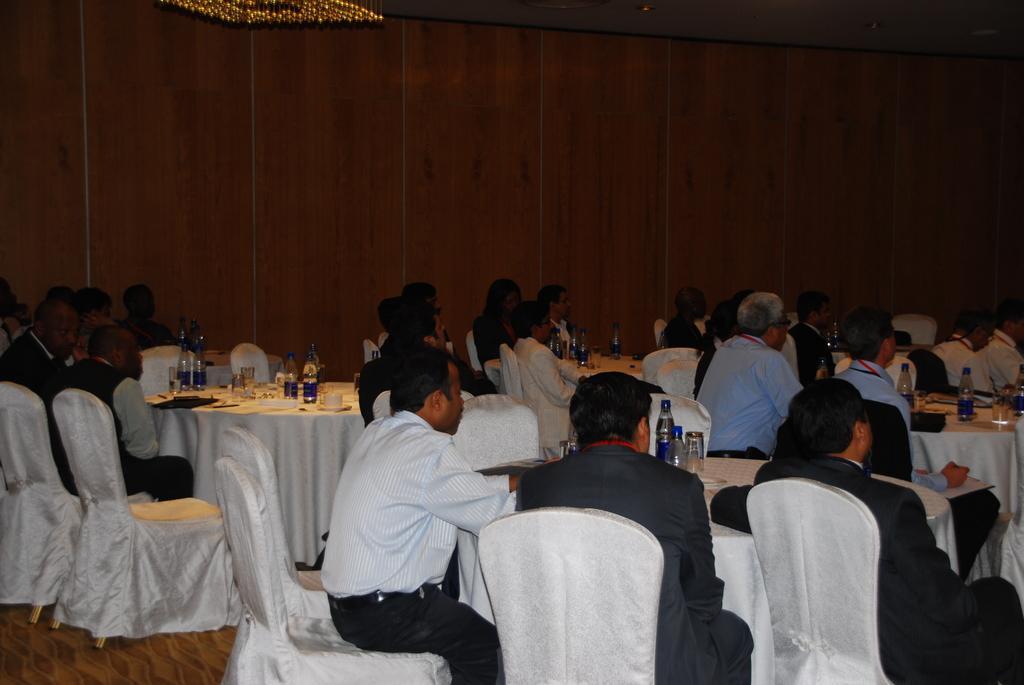Could you give a brief overview of what you see in this image? There are many persons sitting on chairs. There are many chairs and tables in this room. On tables there are bottles glasses, cups and saucer. In the background there is a wall. 